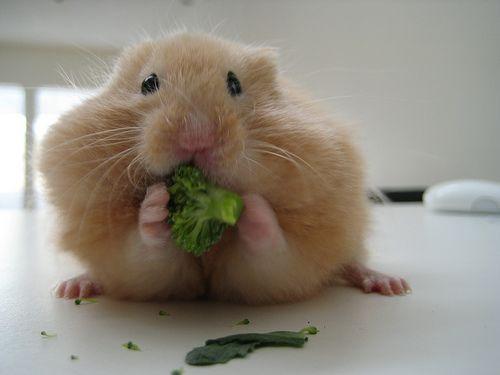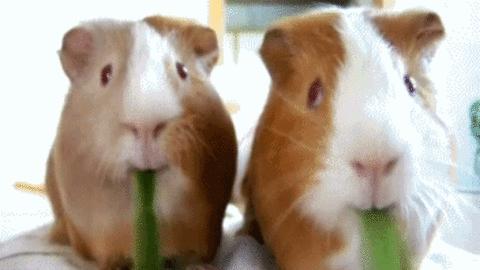The first image is the image on the left, the second image is the image on the right. Analyze the images presented: Is the assertion "One image shows two guinea pigs eating side by side." valid? Answer yes or no. Yes. 